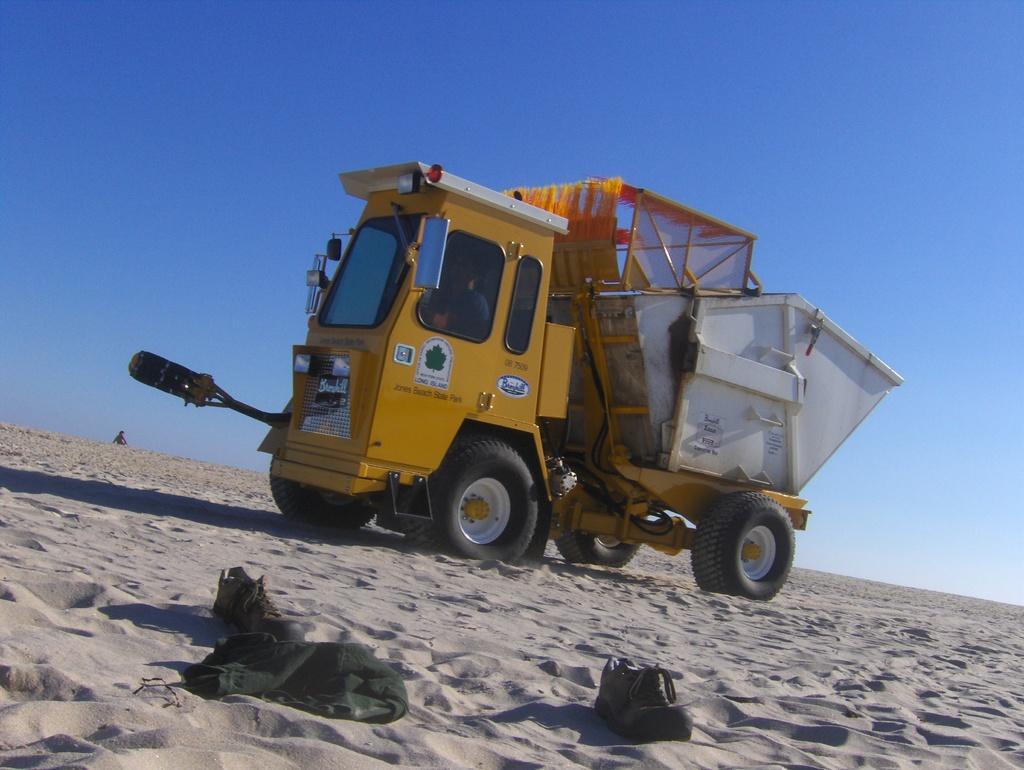Can you describe this image briefly? In this image we can see a truck on the sand, there is a window, there are wheels, there are head lights, there is a mirror, there are shoes on the sand, there is a sky. 